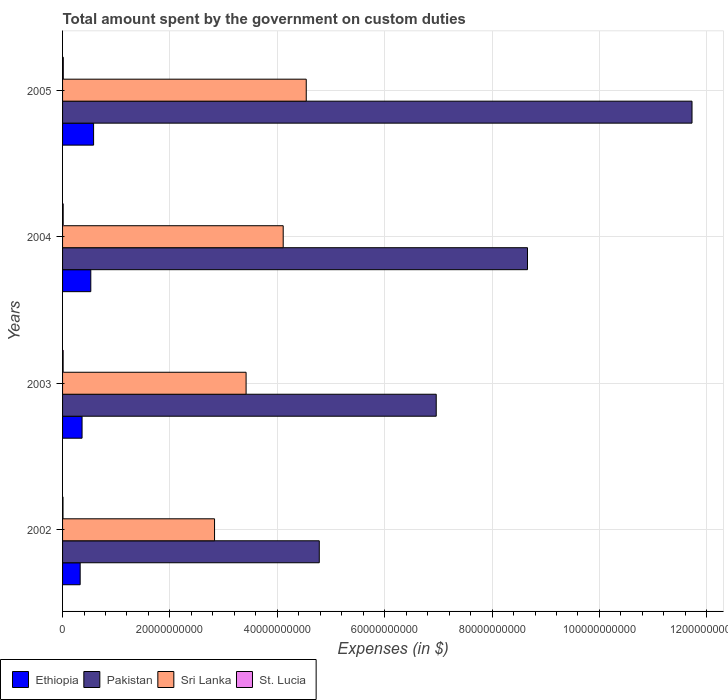How many groups of bars are there?
Make the answer very short. 4. Are the number of bars per tick equal to the number of legend labels?
Give a very brief answer. Yes. How many bars are there on the 1st tick from the top?
Offer a terse response. 4. What is the label of the 2nd group of bars from the top?
Your response must be concise. 2004. In how many cases, is the number of bars for a given year not equal to the number of legend labels?
Provide a short and direct response. 0. What is the amount spent on custom duties by the government in St. Lucia in 2003?
Provide a short and direct response. 1.07e+08. Across all years, what is the maximum amount spent on custom duties by the government in Sri Lanka?
Provide a short and direct response. 4.54e+1. Across all years, what is the minimum amount spent on custom duties by the government in St. Lucia?
Ensure brevity in your answer.  8.15e+07. What is the total amount spent on custom duties by the government in St. Lucia in the graph?
Offer a very short reply. 4.41e+08. What is the difference between the amount spent on custom duties by the government in Ethiopia in 2004 and that in 2005?
Keep it short and to the point. -5.22e+08. What is the difference between the amount spent on custom duties by the government in Pakistan in 2005 and the amount spent on custom duties by the government in Ethiopia in 2003?
Keep it short and to the point. 1.14e+11. What is the average amount spent on custom duties by the government in St. Lucia per year?
Provide a succinct answer. 1.10e+08. In the year 2004, what is the difference between the amount spent on custom duties by the government in St. Lucia and amount spent on custom duties by the government in Ethiopia?
Offer a terse response. -5.14e+09. What is the ratio of the amount spent on custom duties by the government in St. Lucia in 2002 to that in 2005?
Make the answer very short. 0.6. Is the amount spent on custom duties by the government in Pakistan in 2002 less than that in 2004?
Give a very brief answer. Yes. What is the difference between the highest and the second highest amount spent on custom duties by the government in St. Lucia?
Give a very brief answer. 1.90e+07. What is the difference between the highest and the lowest amount spent on custom duties by the government in St. Lucia?
Provide a succinct answer. 5.43e+07. In how many years, is the amount spent on custom duties by the government in Sri Lanka greater than the average amount spent on custom duties by the government in Sri Lanka taken over all years?
Provide a short and direct response. 2. What does the 1st bar from the top in 2003 represents?
Provide a short and direct response. St. Lucia. What does the 4th bar from the bottom in 2002 represents?
Make the answer very short. St. Lucia. How many bars are there?
Your answer should be very brief. 16. How many years are there in the graph?
Provide a short and direct response. 4. Does the graph contain any zero values?
Provide a succinct answer. No. Where does the legend appear in the graph?
Your answer should be very brief. Bottom left. How are the legend labels stacked?
Give a very brief answer. Horizontal. What is the title of the graph?
Make the answer very short. Total amount spent by the government on custom duties. What is the label or title of the X-axis?
Give a very brief answer. Expenses (in $). What is the Expenses (in $) in Ethiopia in 2002?
Provide a succinct answer. 3.28e+09. What is the Expenses (in $) of Pakistan in 2002?
Provide a succinct answer. 4.78e+1. What is the Expenses (in $) of Sri Lanka in 2002?
Ensure brevity in your answer.  2.83e+1. What is the Expenses (in $) in St. Lucia in 2002?
Your answer should be compact. 8.15e+07. What is the Expenses (in $) in Ethiopia in 2003?
Your response must be concise. 3.63e+09. What is the Expenses (in $) in Pakistan in 2003?
Ensure brevity in your answer.  6.96e+1. What is the Expenses (in $) of Sri Lanka in 2003?
Provide a short and direct response. 3.42e+1. What is the Expenses (in $) of St. Lucia in 2003?
Your answer should be compact. 1.07e+08. What is the Expenses (in $) of Ethiopia in 2004?
Give a very brief answer. 5.26e+09. What is the Expenses (in $) of Pakistan in 2004?
Keep it short and to the point. 8.66e+1. What is the Expenses (in $) of Sri Lanka in 2004?
Provide a succinct answer. 4.11e+1. What is the Expenses (in $) in St. Lucia in 2004?
Ensure brevity in your answer.  1.17e+08. What is the Expenses (in $) of Ethiopia in 2005?
Keep it short and to the point. 5.78e+09. What is the Expenses (in $) of Pakistan in 2005?
Keep it short and to the point. 1.17e+11. What is the Expenses (in $) of Sri Lanka in 2005?
Offer a terse response. 4.54e+1. What is the Expenses (in $) in St. Lucia in 2005?
Your response must be concise. 1.36e+08. Across all years, what is the maximum Expenses (in $) in Ethiopia?
Give a very brief answer. 5.78e+09. Across all years, what is the maximum Expenses (in $) of Pakistan?
Your answer should be very brief. 1.17e+11. Across all years, what is the maximum Expenses (in $) in Sri Lanka?
Your answer should be very brief. 4.54e+1. Across all years, what is the maximum Expenses (in $) in St. Lucia?
Keep it short and to the point. 1.36e+08. Across all years, what is the minimum Expenses (in $) in Ethiopia?
Give a very brief answer. 3.28e+09. Across all years, what is the minimum Expenses (in $) in Pakistan?
Offer a very short reply. 4.78e+1. Across all years, what is the minimum Expenses (in $) in Sri Lanka?
Provide a succinct answer. 2.83e+1. Across all years, what is the minimum Expenses (in $) in St. Lucia?
Make the answer very short. 8.15e+07. What is the total Expenses (in $) of Ethiopia in the graph?
Your answer should be very brief. 1.79e+1. What is the total Expenses (in $) of Pakistan in the graph?
Keep it short and to the point. 3.21e+11. What is the total Expenses (in $) of Sri Lanka in the graph?
Provide a succinct answer. 1.49e+11. What is the total Expenses (in $) in St. Lucia in the graph?
Provide a succinct answer. 4.41e+08. What is the difference between the Expenses (in $) of Ethiopia in 2002 and that in 2003?
Make the answer very short. -3.55e+08. What is the difference between the Expenses (in $) of Pakistan in 2002 and that in 2003?
Offer a very short reply. -2.18e+1. What is the difference between the Expenses (in $) in Sri Lanka in 2002 and that in 2003?
Provide a succinct answer. -5.88e+09. What is the difference between the Expenses (in $) in St. Lucia in 2002 and that in 2003?
Ensure brevity in your answer.  -2.55e+07. What is the difference between the Expenses (in $) in Ethiopia in 2002 and that in 2004?
Your response must be concise. -1.98e+09. What is the difference between the Expenses (in $) in Pakistan in 2002 and that in 2004?
Offer a terse response. -3.88e+1. What is the difference between the Expenses (in $) of Sri Lanka in 2002 and that in 2004?
Make the answer very short. -1.28e+1. What is the difference between the Expenses (in $) of St. Lucia in 2002 and that in 2004?
Your answer should be compact. -3.53e+07. What is the difference between the Expenses (in $) in Ethiopia in 2002 and that in 2005?
Offer a very short reply. -2.50e+09. What is the difference between the Expenses (in $) of Pakistan in 2002 and that in 2005?
Your response must be concise. -6.94e+1. What is the difference between the Expenses (in $) of Sri Lanka in 2002 and that in 2005?
Keep it short and to the point. -1.71e+1. What is the difference between the Expenses (in $) in St. Lucia in 2002 and that in 2005?
Your answer should be compact. -5.43e+07. What is the difference between the Expenses (in $) of Ethiopia in 2003 and that in 2004?
Give a very brief answer. -1.63e+09. What is the difference between the Expenses (in $) of Pakistan in 2003 and that in 2004?
Ensure brevity in your answer.  -1.70e+1. What is the difference between the Expenses (in $) in Sri Lanka in 2003 and that in 2004?
Keep it short and to the point. -6.91e+09. What is the difference between the Expenses (in $) in St. Lucia in 2003 and that in 2004?
Offer a terse response. -9.80e+06. What is the difference between the Expenses (in $) in Ethiopia in 2003 and that in 2005?
Offer a terse response. -2.15e+09. What is the difference between the Expenses (in $) of Pakistan in 2003 and that in 2005?
Keep it short and to the point. -4.76e+1. What is the difference between the Expenses (in $) in Sri Lanka in 2003 and that in 2005?
Ensure brevity in your answer.  -1.12e+1. What is the difference between the Expenses (in $) in St. Lucia in 2003 and that in 2005?
Provide a short and direct response. -2.88e+07. What is the difference between the Expenses (in $) of Ethiopia in 2004 and that in 2005?
Offer a terse response. -5.22e+08. What is the difference between the Expenses (in $) in Pakistan in 2004 and that in 2005?
Your response must be concise. -3.06e+1. What is the difference between the Expenses (in $) of Sri Lanka in 2004 and that in 2005?
Make the answer very short. -4.29e+09. What is the difference between the Expenses (in $) of St. Lucia in 2004 and that in 2005?
Provide a succinct answer. -1.90e+07. What is the difference between the Expenses (in $) in Ethiopia in 2002 and the Expenses (in $) in Pakistan in 2003?
Offer a very short reply. -6.63e+1. What is the difference between the Expenses (in $) of Ethiopia in 2002 and the Expenses (in $) of Sri Lanka in 2003?
Make the answer very short. -3.09e+1. What is the difference between the Expenses (in $) in Ethiopia in 2002 and the Expenses (in $) in St. Lucia in 2003?
Make the answer very short. 3.17e+09. What is the difference between the Expenses (in $) of Pakistan in 2002 and the Expenses (in $) of Sri Lanka in 2003?
Offer a terse response. 1.36e+1. What is the difference between the Expenses (in $) in Pakistan in 2002 and the Expenses (in $) in St. Lucia in 2003?
Offer a terse response. 4.77e+1. What is the difference between the Expenses (in $) of Sri Lanka in 2002 and the Expenses (in $) of St. Lucia in 2003?
Offer a terse response. 2.82e+1. What is the difference between the Expenses (in $) of Ethiopia in 2002 and the Expenses (in $) of Pakistan in 2004?
Offer a terse response. -8.33e+1. What is the difference between the Expenses (in $) of Ethiopia in 2002 and the Expenses (in $) of Sri Lanka in 2004?
Keep it short and to the point. -3.78e+1. What is the difference between the Expenses (in $) of Ethiopia in 2002 and the Expenses (in $) of St. Lucia in 2004?
Offer a terse response. 3.16e+09. What is the difference between the Expenses (in $) in Pakistan in 2002 and the Expenses (in $) in Sri Lanka in 2004?
Your response must be concise. 6.72e+09. What is the difference between the Expenses (in $) in Pakistan in 2002 and the Expenses (in $) in St. Lucia in 2004?
Your answer should be very brief. 4.77e+1. What is the difference between the Expenses (in $) in Sri Lanka in 2002 and the Expenses (in $) in St. Lucia in 2004?
Your answer should be very brief. 2.82e+1. What is the difference between the Expenses (in $) in Ethiopia in 2002 and the Expenses (in $) in Pakistan in 2005?
Offer a very short reply. -1.14e+11. What is the difference between the Expenses (in $) in Ethiopia in 2002 and the Expenses (in $) in Sri Lanka in 2005?
Offer a terse response. -4.21e+1. What is the difference between the Expenses (in $) in Ethiopia in 2002 and the Expenses (in $) in St. Lucia in 2005?
Your answer should be compact. 3.14e+09. What is the difference between the Expenses (in $) of Pakistan in 2002 and the Expenses (in $) of Sri Lanka in 2005?
Make the answer very short. 2.43e+09. What is the difference between the Expenses (in $) in Pakistan in 2002 and the Expenses (in $) in St. Lucia in 2005?
Ensure brevity in your answer.  4.77e+1. What is the difference between the Expenses (in $) in Sri Lanka in 2002 and the Expenses (in $) in St. Lucia in 2005?
Make the answer very short. 2.82e+1. What is the difference between the Expenses (in $) in Ethiopia in 2003 and the Expenses (in $) in Pakistan in 2004?
Provide a succinct answer. -8.30e+1. What is the difference between the Expenses (in $) in Ethiopia in 2003 and the Expenses (in $) in Sri Lanka in 2004?
Ensure brevity in your answer.  -3.75e+1. What is the difference between the Expenses (in $) in Ethiopia in 2003 and the Expenses (in $) in St. Lucia in 2004?
Offer a terse response. 3.52e+09. What is the difference between the Expenses (in $) of Pakistan in 2003 and the Expenses (in $) of Sri Lanka in 2004?
Your answer should be very brief. 2.85e+1. What is the difference between the Expenses (in $) of Pakistan in 2003 and the Expenses (in $) of St. Lucia in 2004?
Ensure brevity in your answer.  6.95e+1. What is the difference between the Expenses (in $) in Sri Lanka in 2003 and the Expenses (in $) in St. Lucia in 2004?
Your answer should be very brief. 3.41e+1. What is the difference between the Expenses (in $) of Ethiopia in 2003 and the Expenses (in $) of Pakistan in 2005?
Provide a short and direct response. -1.14e+11. What is the difference between the Expenses (in $) in Ethiopia in 2003 and the Expenses (in $) in Sri Lanka in 2005?
Keep it short and to the point. -4.18e+1. What is the difference between the Expenses (in $) of Ethiopia in 2003 and the Expenses (in $) of St. Lucia in 2005?
Your response must be concise. 3.50e+09. What is the difference between the Expenses (in $) in Pakistan in 2003 and the Expenses (in $) in Sri Lanka in 2005?
Provide a short and direct response. 2.42e+1. What is the difference between the Expenses (in $) of Pakistan in 2003 and the Expenses (in $) of St. Lucia in 2005?
Your answer should be very brief. 6.95e+1. What is the difference between the Expenses (in $) in Sri Lanka in 2003 and the Expenses (in $) in St. Lucia in 2005?
Your answer should be very brief. 3.40e+1. What is the difference between the Expenses (in $) in Ethiopia in 2004 and the Expenses (in $) in Pakistan in 2005?
Make the answer very short. -1.12e+11. What is the difference between the Expenses (in $) of Ethiopia in 2004 and the Expenses (in $) of Sri Lanka in 2005?
Give a very brief answer. -4.01e+1. What is the difference between the Expenses (in $) in Ethiopia in 2004 and the Expenses (in $) in St. Lucia in 2005?
Offer a very short reply. 5.12e+09. What is the difference between the Expenses (in $) in Pakistan in 2004 and the Expenses (in $) in Sri Lanka in 2005?
Make the answer very short. 4.12e+1. What is the difference between the Expenses (in $) in Pakistan in 2004 and the Expenses (in $) in St. Lucia in 2005?
Your response must be concise. 8.65e+1. What is the difference between the Expenses (in $) in Sri Lanka in 2004 and the Expenses (in $) in St. Lucia in 2005?
Ensure brevity in your answer.  4.10e+1. What is the average Expenses (in $) in Ethiopia per year?
Make the answer very short. 4.49e+09. What is the average Expenses (in $) in Pakistan per year?
Offer a terse response. 8.03e+1. What is the average Expenses (in $) of Sri Lanka per year?
Your response must be concise. 3.72e+1. What is the average Expenses (in $) in St. Lucia per year?
Your answer should be compact. 1.10e+08. In the year 2002, what is the difference between the Expenses (in $) of Ethiopia and Expenses (in $) of Pakistan?
Ensure brevity in your answer.  -4.45e+1. In the year 2002, what is the difference between the Expenses (in $) in Ethiopia and Expenses (in $) in Sri Lanka?
Your answer should be very brief. -2.50e+1. In the year 2002, what is the difference between the Expenses (in $) of Ethiopia and Expenses (in $) of St. Lucia?
Give a very brief answer. 3.20e+09. In the year 2002, what is the difference between the Expenses (in $) of Pakistan and Expenses (in $) of Sri Lanka?
Offer a terse response. 1.95e+1. In the year 2002, what is the difference between the Expenses (in $) in Pakistan and Expenses (in $) in St. Lucia?
Give a very brief answer. 4.77e+1. In the year 2002, what is the difference between the Expenses (in $) of Sri Lanka and Expenses (in $) of St. Lucia?
Provide a succinct answer. 2.82e+1. In the year 2003, what is the difference between the Expenses (in $) in Ethiopia and Expenses (in $) in Pakistan?
Your response must be concise. -6.60e+1. In the year 2003, what is the difference between the Expenses (in $) in Ethiopia and Expenses (in $) in Sri Lanka?
Your answer should be very brief. -3.06e+1. In the year 2003, what is the difference between the Expenses (in $) in Ethiopia and Expenses (in $) in St. Lucia?
Keep it short and to the point. 3.53e+09. In the year 2003, what is the difference between the Expenses (in $) of Pakistan and Expenses (in $) of Sri Lanka?
Give a very brief answer. 3.54e+1. In the year 2003, what is the difference between the Expenses (in $) of Pakistan and Expenses (in $) of St. Lucia?
Make the answer very short. 6.95e+1. In the year 2003, what is the difference between the Expenses (in $) of Sri Lanka and Expenses (in $) of St. Lucia?
Your answer should be very brief. 3.41e+1. In the year 2004, what is the difference between the Expenses (in $) of Ethiopia and Expenses (in $) of Pakistan?
Offer a terse response. -8.13e+1. In the year 2004, what is the difference between the Expenses (in $) in Ethiopia and Expenses (in $) in Sri Lanka?
Your response must be concise. -3.58e+1. In the year 2004, what is the difference between the Expenses (in $) in Ethiopia and Expenses (in $) in St. Lucia?
Make the answer very short. 5.14e+09. In the year 2004, what is the difference between the Expenses (in $) in Pakistan and Expenses (in $) in Sri Lanka?
Your answer should be very brief. 4.55e+1. In the year 2004, what is the difference between the Expenses (in $) of Pakistan and Expenses (in $) of St. Lucia?
Make the answer very short. 8.65e+1. In the year 2004, what is the difference between the Expenses (in $) in Sri Lanka and Expenses (in $) in St. Lucia?
Give a very brief answer. 4.10e+1. In the year 2005, what is the difference between the Expenses (in $) in Ethiopia and Expenses (in $) in Pakistan?
Your answer should be compact. -1.11e+11. In the year 2005, what is the difference between the Expenses (in $) of Ethiopia and Expenses (in $) of Sri Lanka?
Your answer should be very brief. -3.96e+1. In the year 2005, what is the difference between the Expenses (in $) in Ethiopia and Expenses (in $) in St. Lucia?
Ensure brevity in your answer.  5.64e+09. In the year 2005, what is the difference between the Expenses (in $) in Pakistan and Expenses (in $) in Sri Lanka?
Ensure brevity in your answer.  7.19e+1. In the year 2005, what is the difference between the Expenses (in $) of Pakistan and Expenses (in $) of St. Lucia?
Your answer should be very brief. 1.17e+11. In the year 2005, what is the difference between the Expenses (in $) in Sri Lanka and Expenses (in $) in St. Lucia?
Your answer should be compact. 4.53e+1. What is the ratio of the Expenses (in $) of Ethiopia in 2002 to that in 2003?
Give a very brief answer. 0.9. What is the ratio of the Expenses (in $) of Pakistan in 2002 to that in 2003?
Your answer should be compact. 0.69. What is the ratio of the Expenses (in $) in Sri Lanka in 2002 to that in 2003?
Your response must be concise. 0.83. What is the ratio of the Expenses (in $) of St. Lucia in 2002 to that in 2003?
Provide a succinct answer. 0.76. What is the ratio of the Expenses (in $) in Ethiopia in 2002 to that in 2004?
Provide a short and direct response. 0.62. What is the ratio of the Expenses (in $) in Pakistan in 2002 to that in 2004?
Offer a very short reply. 0.55. What is the ratio of the Expenses (in $) in Sri Lanka in 2002 to that in 2004?
Give a very brief answer. 0.69. What is the ratio of the Expenses (in $) of St. Lucia in 2002 to that in 2004?
Offer a terse response. 0.7. What is the ratio of the Expenses (in $) of Ethiopia in 2002 to that in 2005?
Give a very brief answer. 0.57. What is the ratio of the Expenses (in $) of Pakistan in 2002 to that in 2005?
Ensure brevity in your answer.  0.41. What is the ratio of the Expenses (in $) of Sri Lanka in 2002 to that in 2005?
Your answer should be compact. 0.62. What is the ratio of the Expenses (in $) in St. Lucia in 2002 to that in 2005?
Offer a terse response. 0.6. What is the ratio of the Expenses (in $) of Ethiopia in 2003 to that in 2004?
Your answer should be very brief. 0.69. What is the ratio of the Expenses (in $) in Pakistan in 2003 to that in 2004?
Keep it short and to the point. 0.8. What is the ratio of the Expenses (in $) in Sri Lanka in 2003 to that in 2004?
Offer a terse response. 0.83. What is the ratio of the Expenses (in $) of St. Lucia in 2003 to that in 2004?
Give a very brief answer. 0.92. What is the ratio of the Expenses (in $) of Ethiopia in 2003 to that in 2005?
Provide a succinct answer. 0.63. What is the ratio of the Expenses (in $) in Pakistan in 2003 to that in 2005?
Your answer should be compact. 0.59. What is the ratio of the Expenses (in $) of Sri Lanka in 2003 to that in 2005?
Ensure brevity in your answer.  0.75. What is the ratio of the Expenses (in $) of St. Lucia in 2003 to that in 2005?
Provide a succinct answer. 0.79. What is the ratio of the Expenses (in $) of Ethiopia in 2004 to that in 2005?
Ensure brevity in your answer.  0.91. What is the ratio of the Expenses (in $) of Pakistan in 2004 to that in 2005?
Your answer should be very brief. 0.74. What is the ratio of the Expenses (in $) in Sri Lanka in 2004 to that in 2005?
Your answer should be very brief. 0.91. What is the ratio of the Expenses (in $) of St. Lucia in 2004 to that in 2005?
Give a very brief answer. 0.86. What is the difference between the highest and the second highest Expenses (in $) in Ethiopia?
Keep it short and to the point. 5.22e+08. What is the difference between the highest and the second highest Expenses (in $) of Pakistan?
Provide a succinct answer. 3.06e+1. What is the difference between the highest and the second highest Expenses (in $) in Sri Lanka?
Give a very brief answer. 4.29e+09. What is the difference between the highest and the second highest Expenses (in $) in St. Lucia?
Make the answer very short. 1.90e+07. What is the difference between the highest and the lowest Expenses (in $) in Ethiopia?
Offer a terse response. 2.50e+09. What is the difference between the highest and the lowest Expenses (in $) in Pakistan?
Your answer should be very brief. 6.94e+1. What is the difference between the highest and the lowest Expenses (in $) in Sri Lanka?
Provide a succinct answer. 1.71e+1. What is the difference between the highest and the lowest Expenses (in $) in St. Lucia?
Keep it short and to the point. 5.43e+07. 